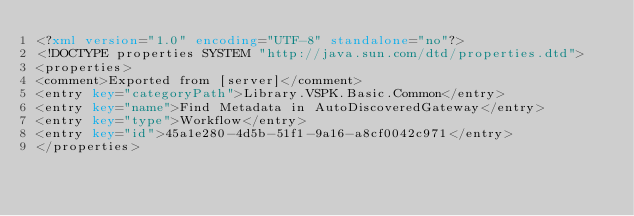<code> <loc_0><loc_0><loc_500><loc_500><_XML_><?xml version="1.0" encoding="UTF-8" standalone="no"?>
<!DOCTYPE properties SYSTEM "http://java.sun.com/dtd/properties.dtd">
<properties>
<comment>Exported from [server]</comment>
<entry key="categoryPath">Library.VSPK.Basic.Common</entry>
<entry key="name">Find Metadata in AutoDiscoveredGateway</entry>
<entry key="type">Workflow</entry>
<entry key="id">45a1e280-4d5b-51f1-9a16-a8cf0042c971</entry>
</properties></code> 